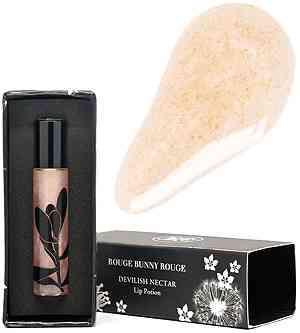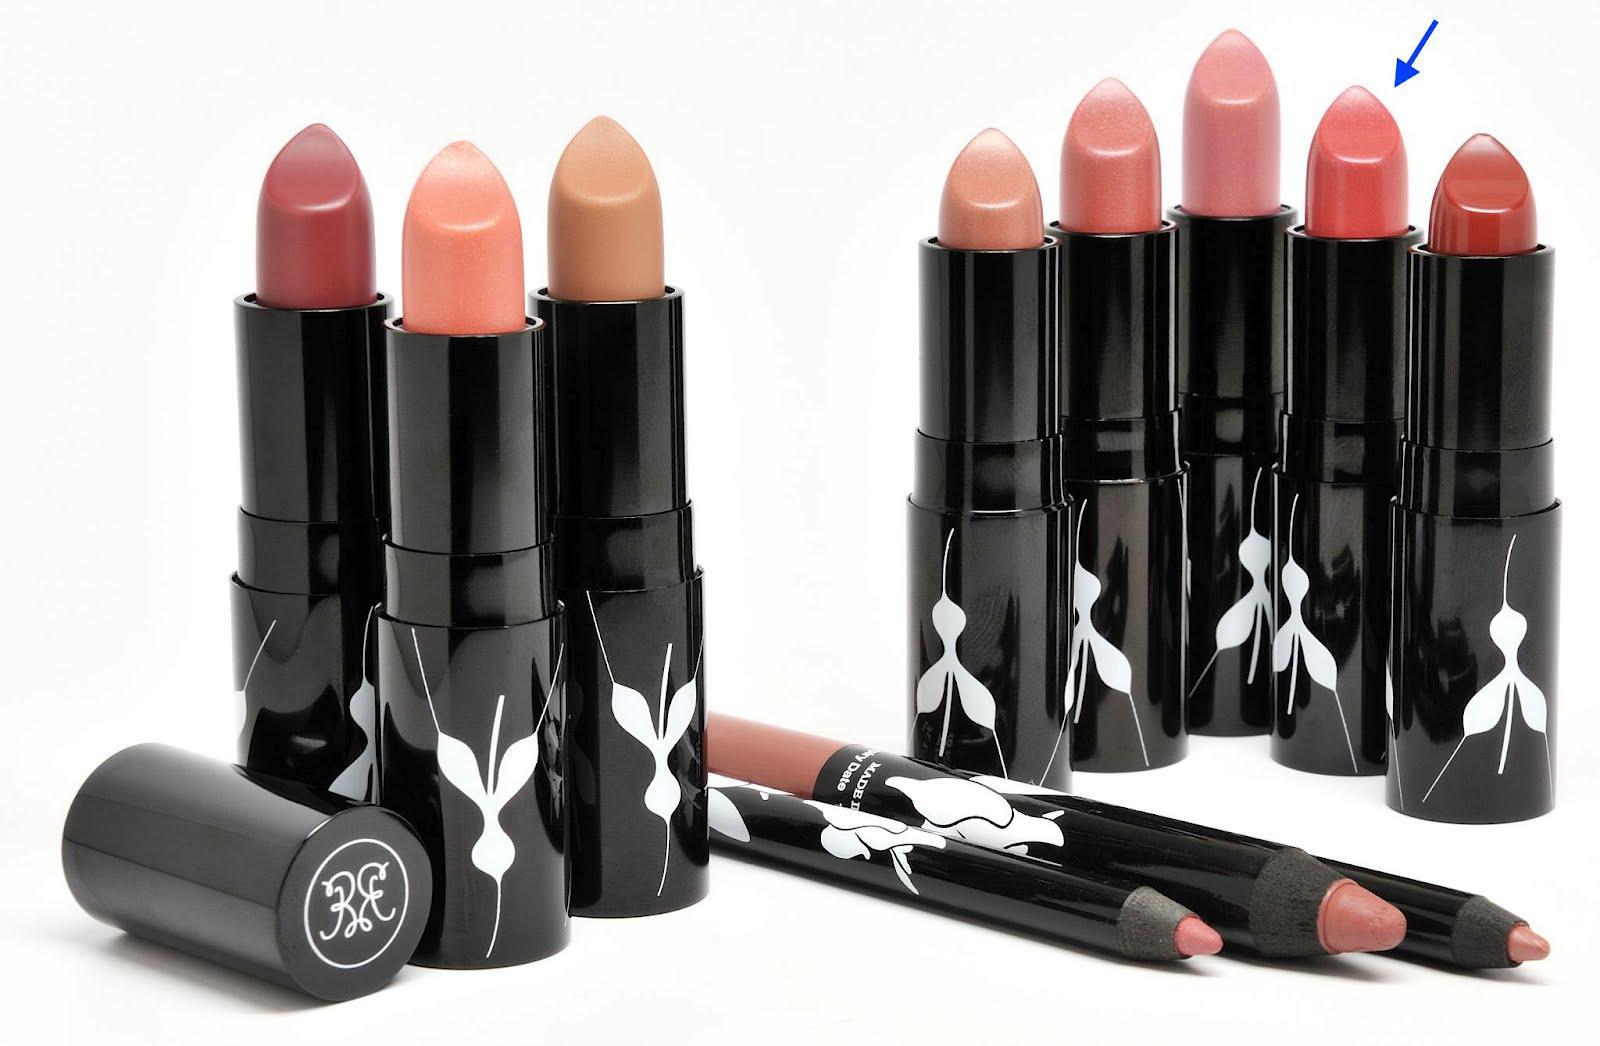The first image is the image on the left, the second image is the image on the right. Evaluate the accuracy of this statement regarding the images: "Lip applicants are displayed in a line of 11 or more.". Is it true? Answer yes or no. Yes. The first image is the image on the left, the second image is the image on the right. Evaluate the accuracy of this statement regarding the images: "there is no more then one lipstick visible in the right side pic". Is it true? Answer yes or no. No. 